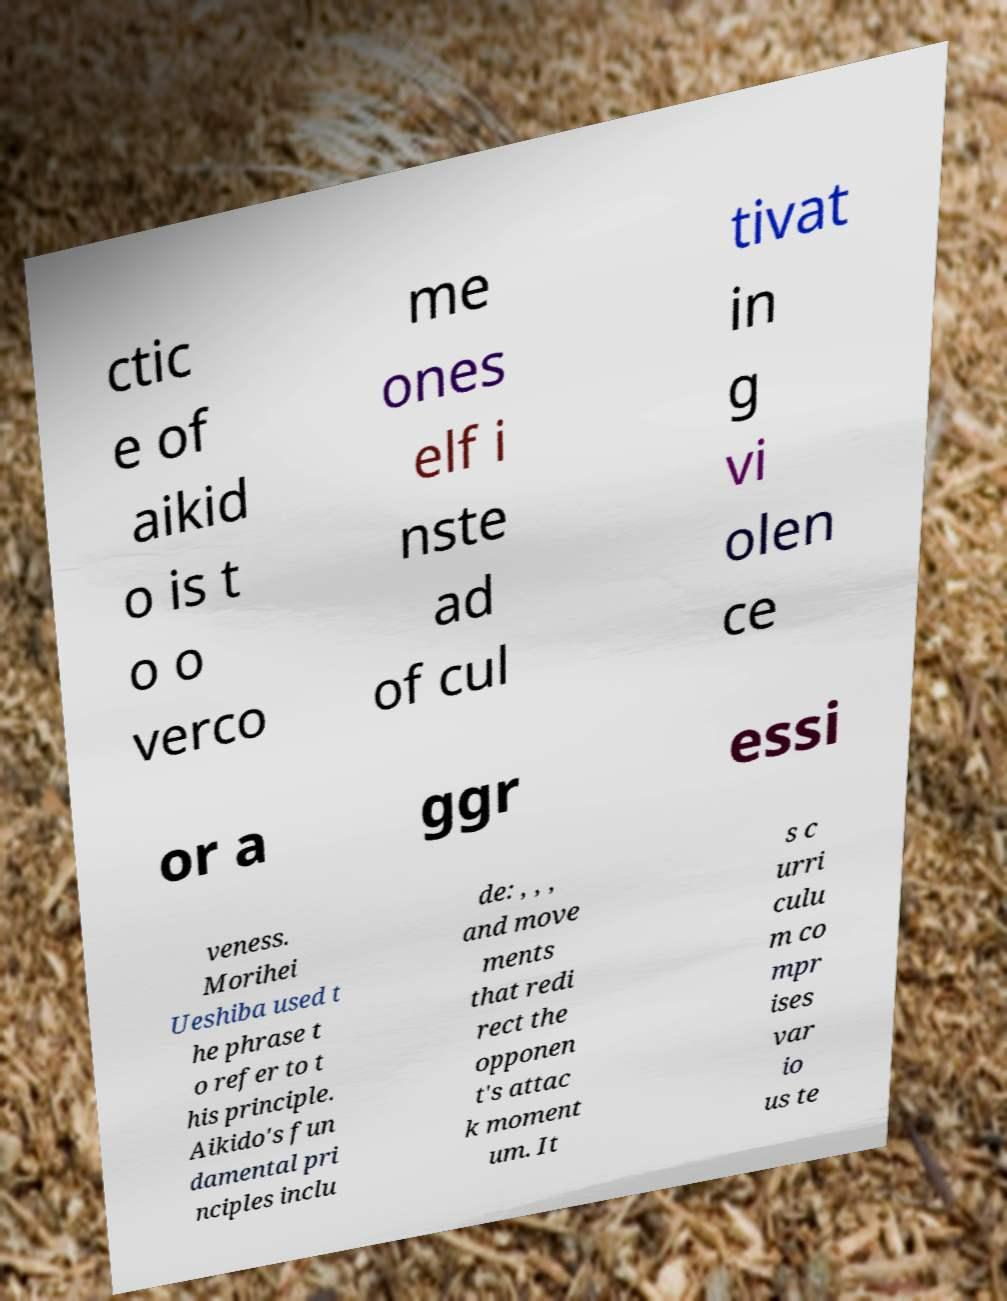Could you assist in decoding the text presented in this image and type it out clearly? ctic e of aikid o is t o o verco me ones elf i nste ad of cul tivat in g vi olen ce or a ggr essi veness. Morihei Ueshiba used t he phrase t o refer to t his principle. Aikido's fun damental pri nciples inclu de: , , , and move ments that redi rect the opponen t's attac k moment um. It s c urri culu m co mpr ises var io us te 